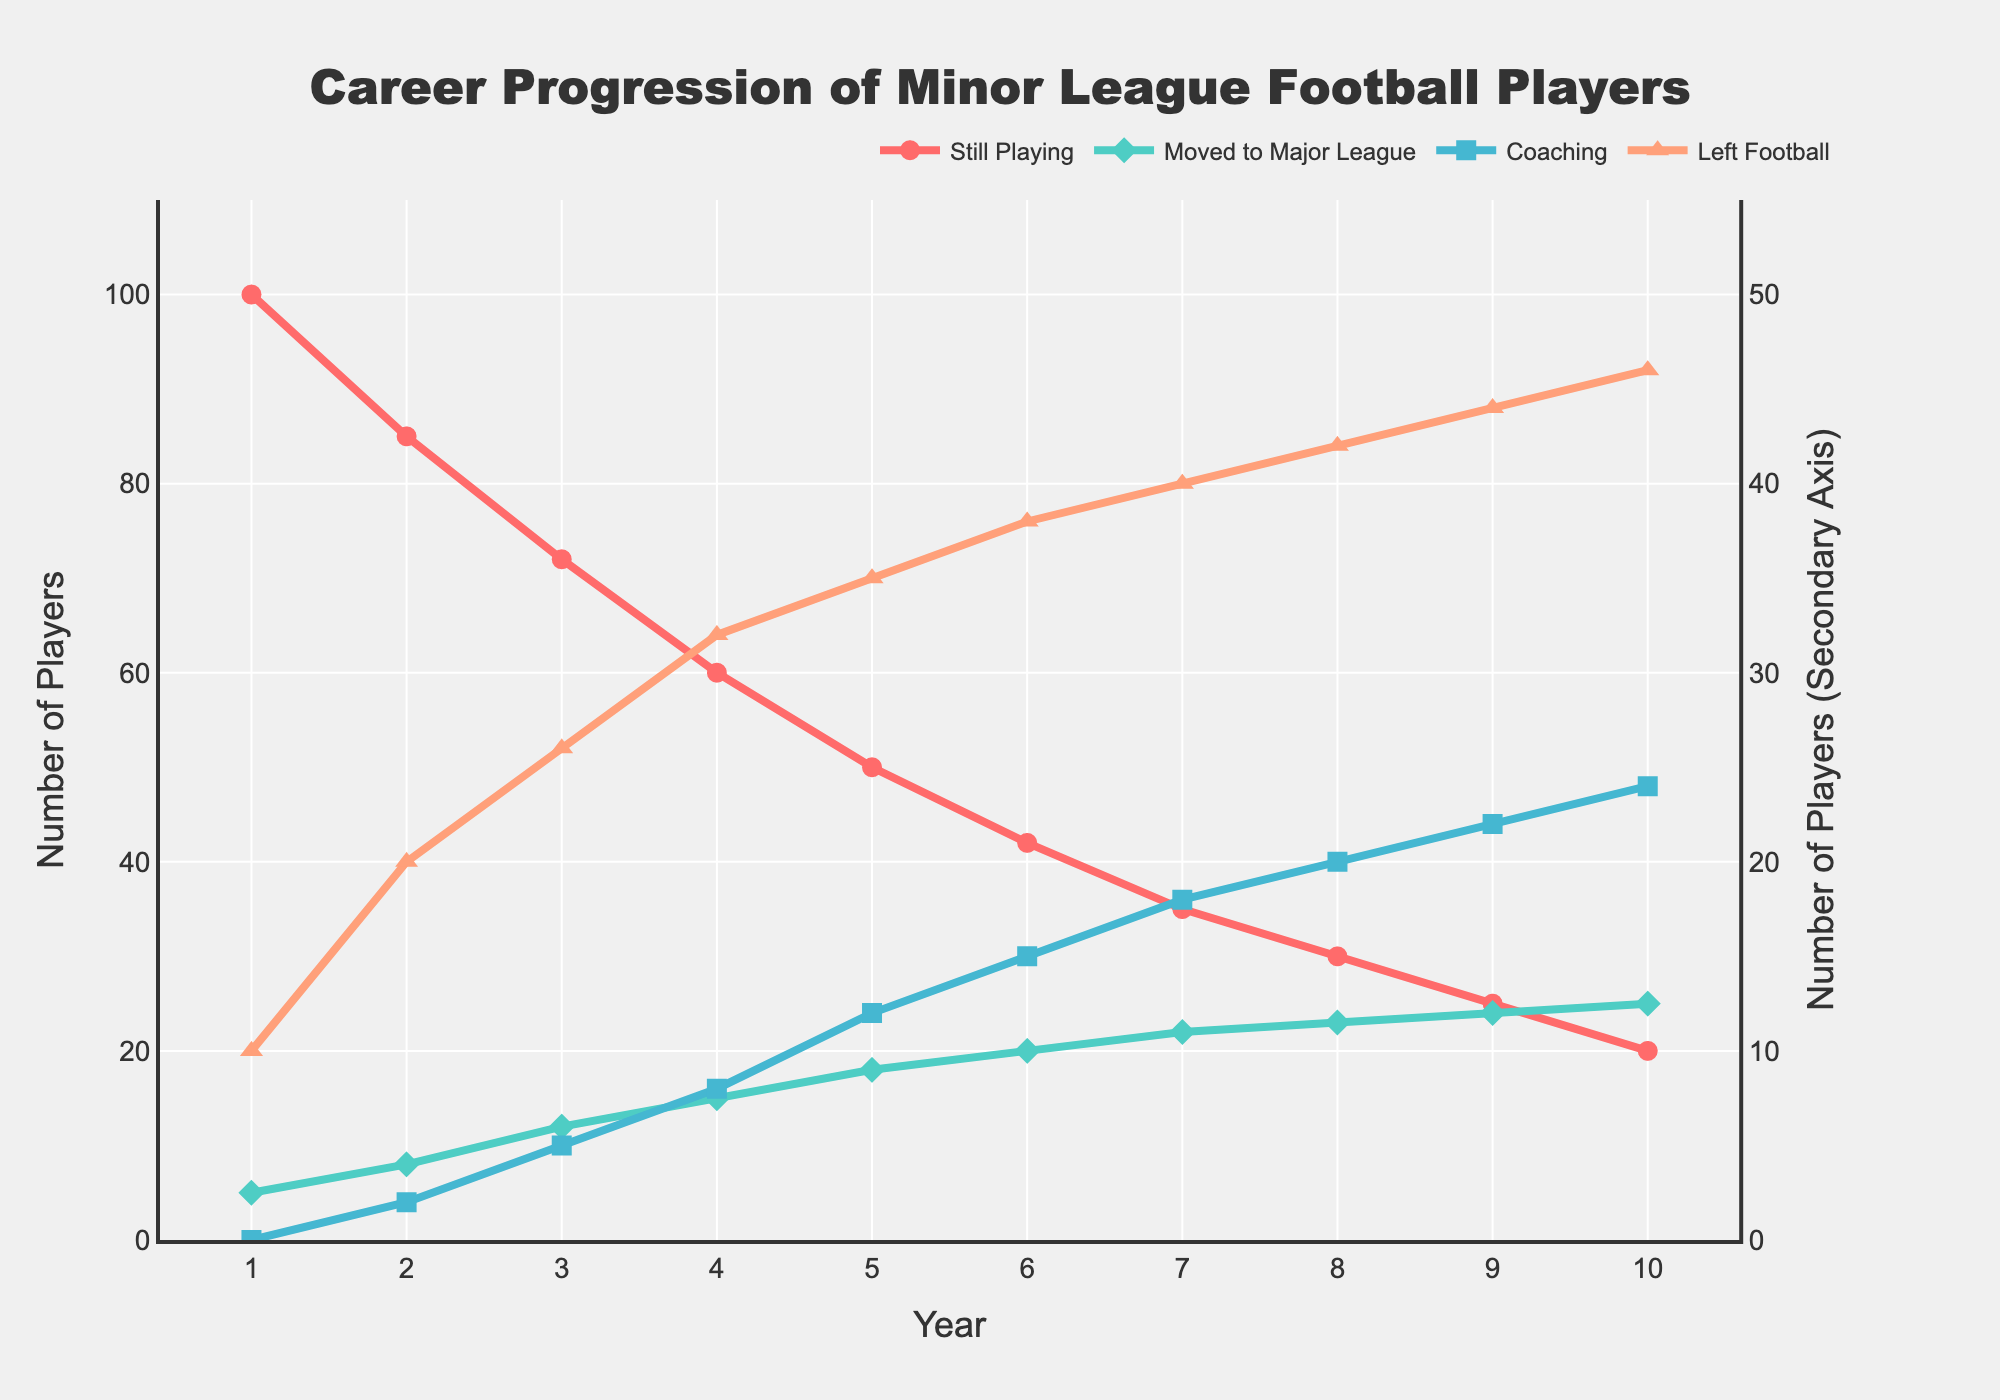what is the trend of players who moved to the major league over the 10-year period? By observing the line representing players who moved to the major league, we see a consistent upward trend from year 1 to year 10. Starting with 5 players in year 1 and increasing to 25 players by year 10.
Answer: Upward trend how many more players were still playing compared to those who moved to the major league in year 3? In year 3, 72 players were still playing, while 12 players moved to the major league. Subtracting these values gives the difference: 72 - 12 = 60.
Answer: 60 what happened to the number of players who left football by year 10 compared to year 1? The line representing players who left football increases from 10 players in year 1 to 46 players in year 10. This shows a consistent increase.
Answer: Increased by 36 comparing the players who went into coaching in year 5 versus year 9, which year had more, and by how much? In year 5, 12 players went into coaching, while in year 9, 22 players did. Subtracting these values shows that year 9 had more by: 22 - 12 = 10 players.
Answer: Year 9 by 10 what is the total number of players still playing and those who moved to the major league by year 4? Summing the players still playing (60) and those who moved to the major league (15) in year 4 gives: 60 + 15 = 75.
Answer: 75 which category had the greatest increase from year 1 to year 10? By examining all the line segments, the category 'Left Football' increased from 10 to 46, showing the largest increment of 36.
Answer: Left Football what is the color of the line representing players who went into coaching? The line representing players who went into coaching is visually indicated with the color blue.
Answer: Blue comparing the trends of 'still playing' and 'left football' categories, which one has a decreasing trend over the years? The 'still playing' category has a consistent downward trend, while the 'left football' category has an upward trend. Thus, 'still playing' is the one with the decreasing trend.
Answer: Still playing In year 6, what is the difference between the number of players who moved to the major league and the number of players who went into coaching? In year 6, 20 players moved to the major league, and 15 went into coaching. The difference is calculated as follows: 20 - 15 = 5.
Answer: 5 what does the visual pattern suggest about the overall career progression trend of minor league football players over the 10 years? The visual pattern overall indicates a decline in players still playing football and an increase in players who left football, moved to the major league, or went into coaching.
Answer: Decline in playing, increase in other categories 